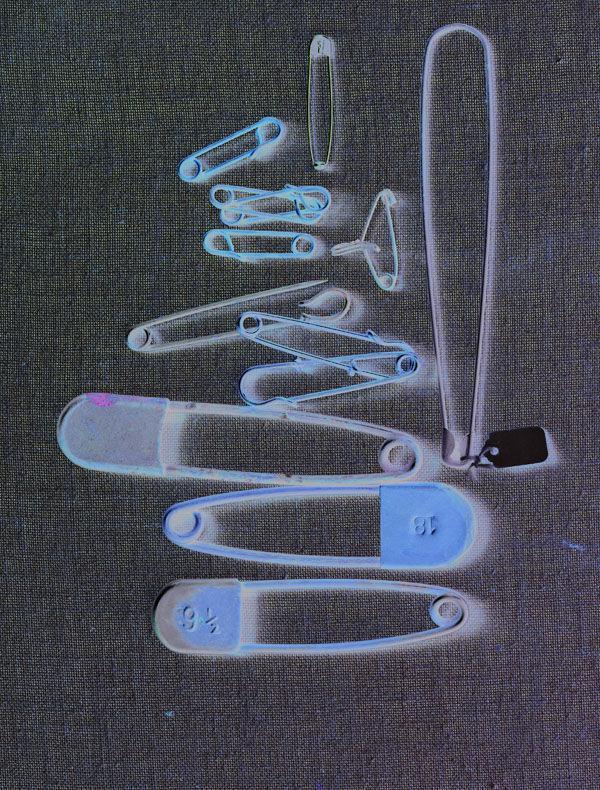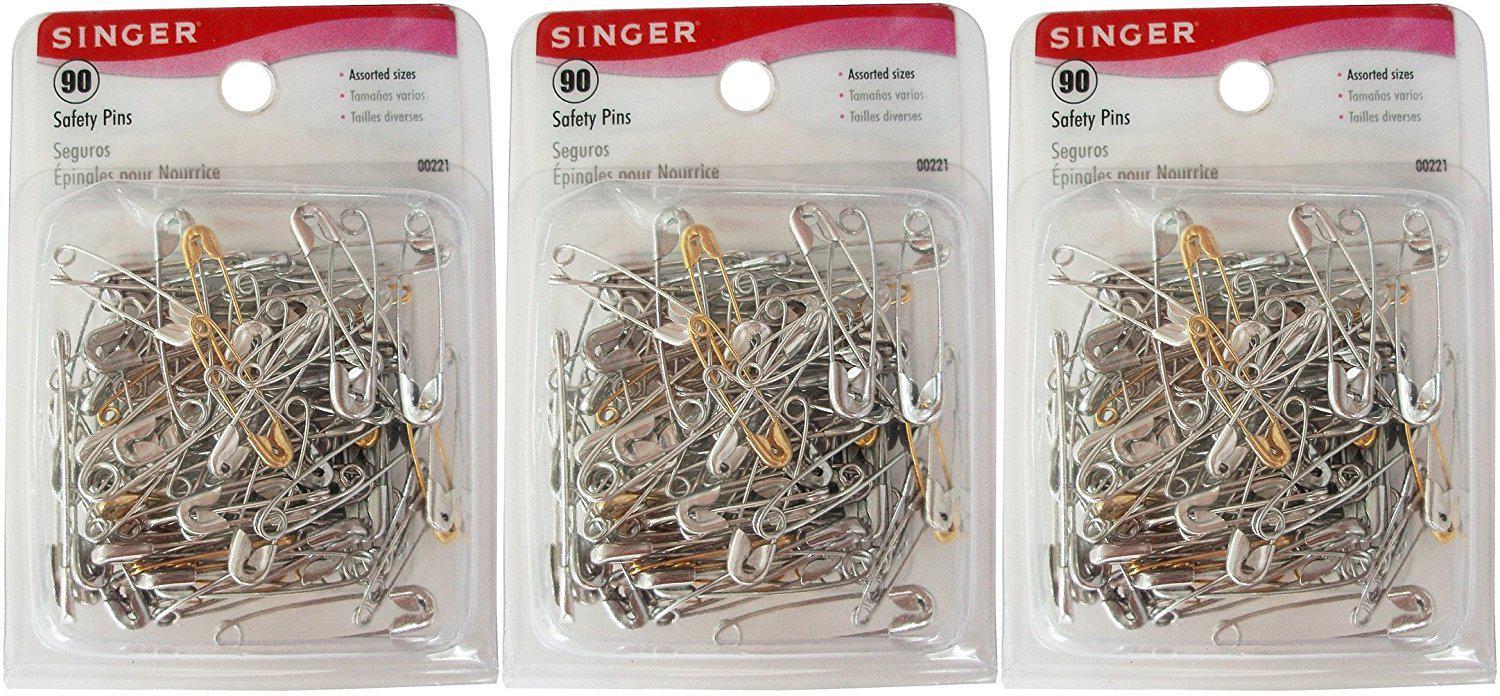The first image is the image on the left, the second image is the image on the right. For the images displayed, is the sentence "The left image shows safety pins arranged in a kind of checkerboard pattern, and the right image includes at least one vertical safety pin depiction." factually correct? Answer yes or no. No. The first image is the image on the left, the second image is the image on the right. Considering the images on both sides, is "there are 5 safety pins" valid? Answer yes or no. No. 